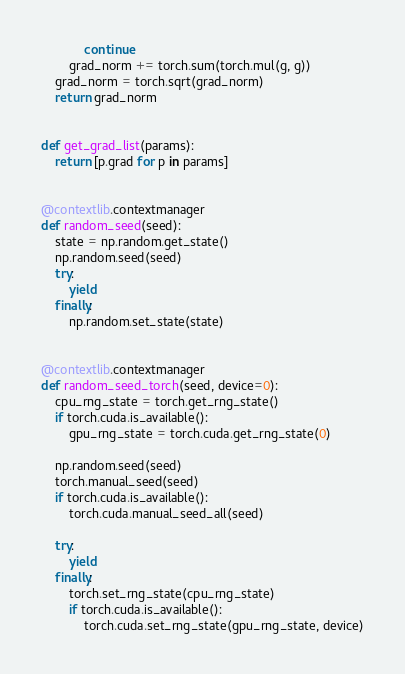<code> <loc_0><loc_0><loc_500><loc_500><_Python_>            continue
        grad_norm += torch.sum(torch.mul(g, g))
    grad_norm = torch.sqrt(grad_norm)
    return grad_norm


def get_grad_list(params):
    return [p.grad for p in params]


@contextlib.contextmanager
def random_seed(seed):
    state = np.random.get_state()
    np.random.seed(seed)
    try:
        yield
    finally:
        np.random.set_state(state)


@contextlib.contextmanager
def random_seed_torch(seed, device=0):
    cpu_rng_state = torch.get_rng_state()
    if torch.cuda.is_available():
        gpu_rng_state = torch.cuda.get_rng_state(0)

    np.random.seed(seed)
    torch.manual_seed(seed)
    if torch.cuda.is_available():
        torch.cuda.manual_seed_all(seed)

    try:
        yield
    finally:
        torch.set_rng_state(cpu_rng_state)
        if torch.cuda.is_available():
            torch.cuda.set_rng_state(gpu_rng_state, device)
</code> 